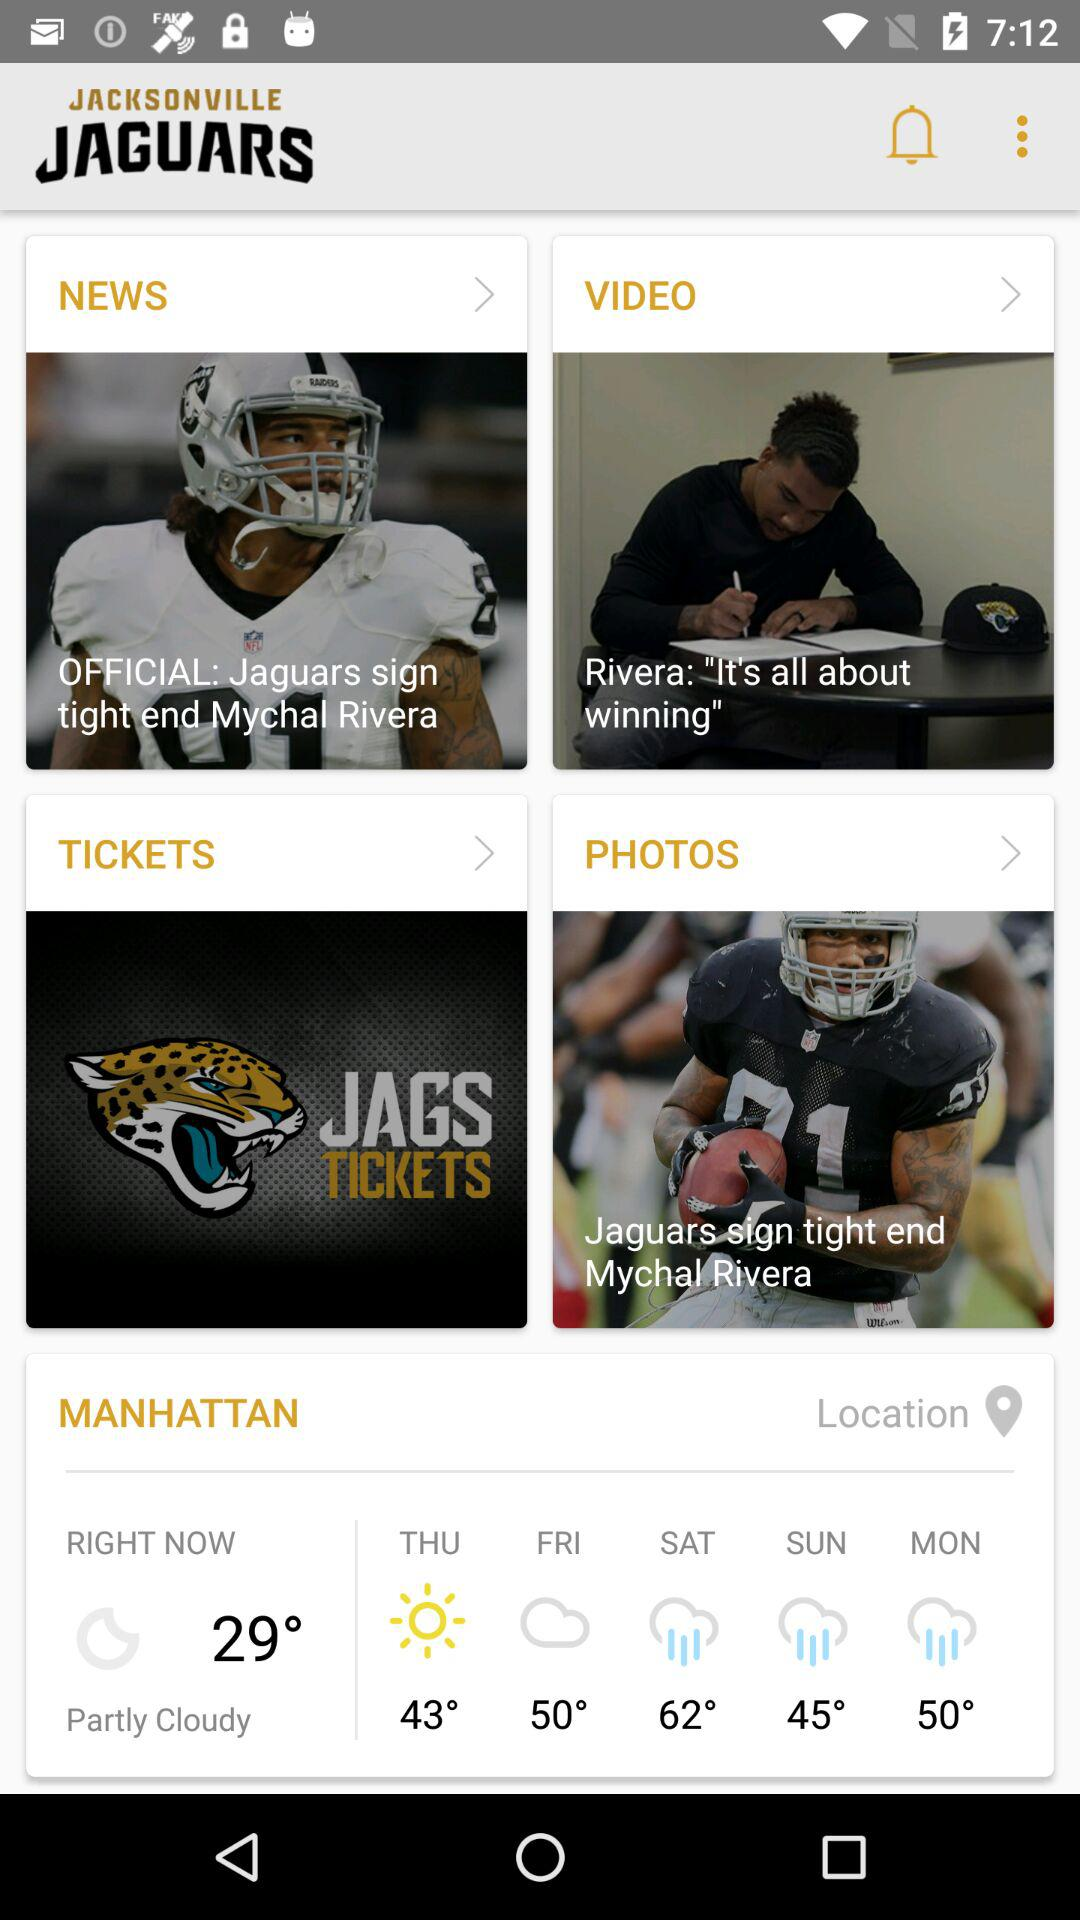On what day did the temperature reach 43 degrees? The day was Thursday. 